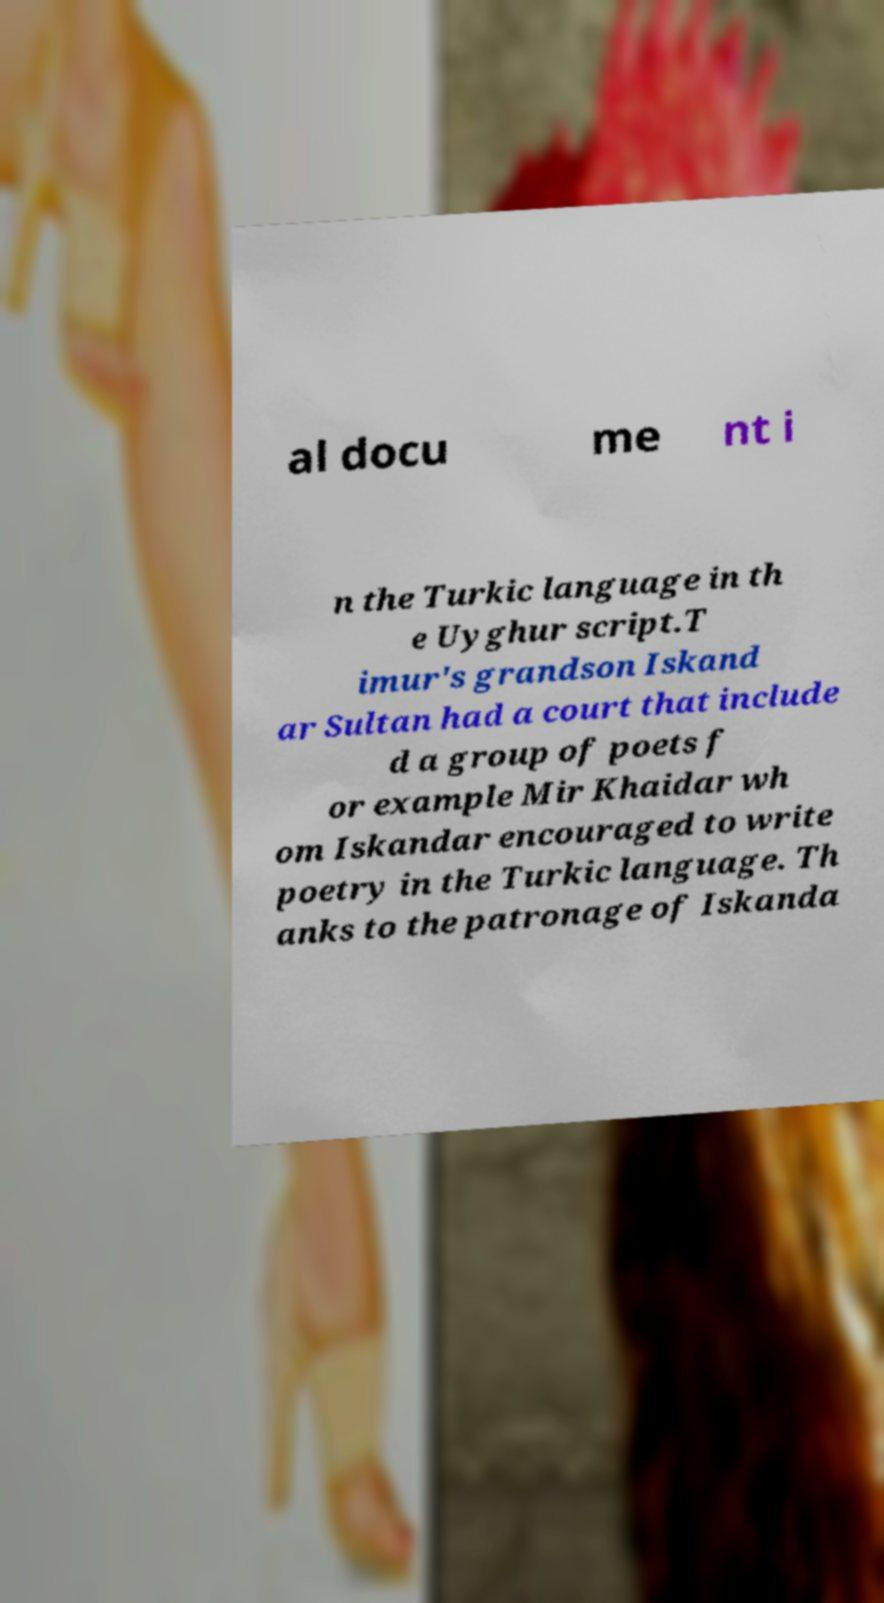There's text embedded in this image that I need extracted. Can you transcribe it verbatim? al docu me nt i n the Turkic language in th e Uyghur script.T imur's grandson Iskand ar Sultan had a court that include d a group of poets f or example Mir Khaidar wh om Iskandar encouraged to write poetry in the Turkic language. Th anks to the patronage of Iskanda 